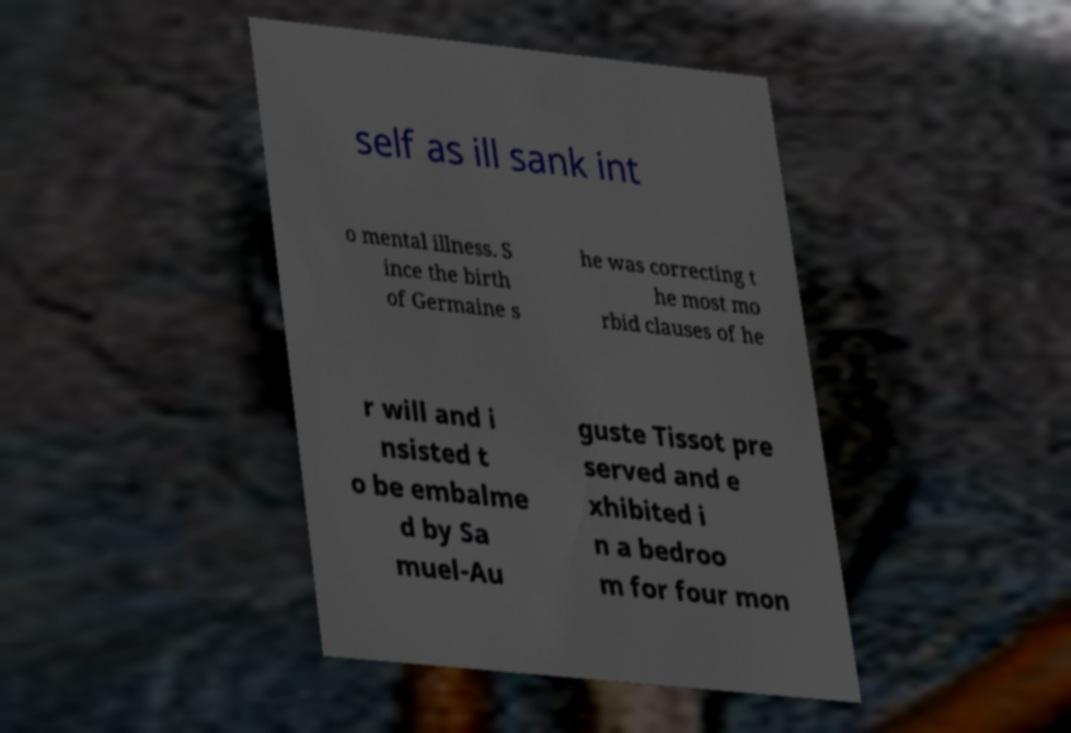I need the written content from this picture converted into text. Can you do that? self as ill sank int o mental illness. S ince the birth of Germaine s he was correcting t he most mo rbid clauses of he r will and i nsisted t o be embalme d by Sa muel-Au guste Tissot pre served and e xhibited i n a bedroo m for four mon 